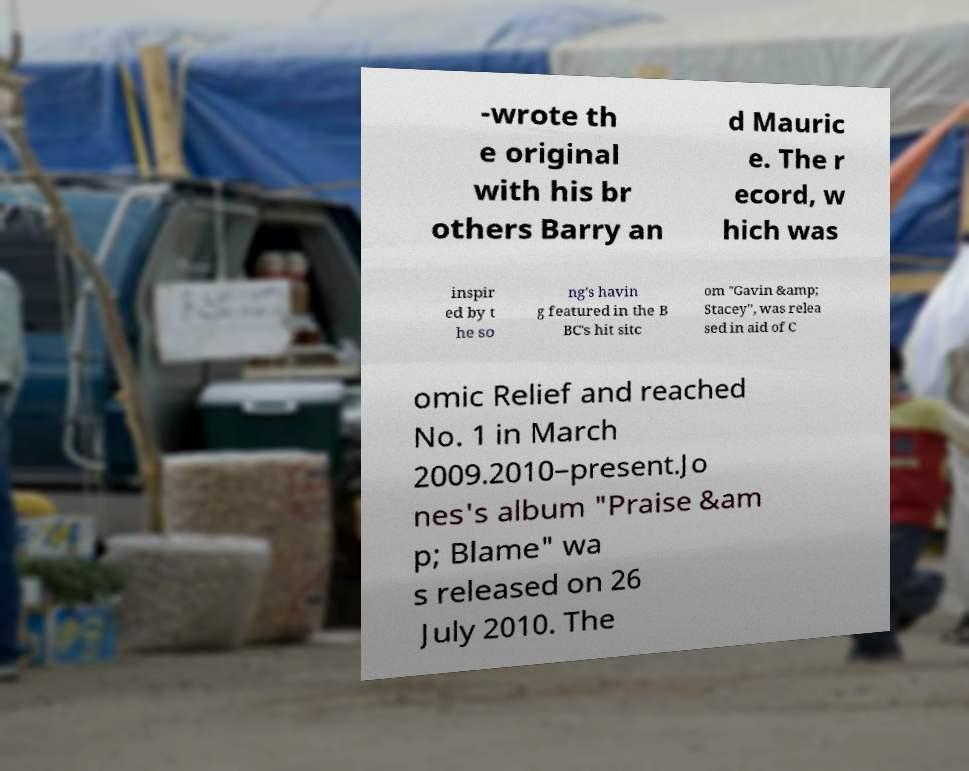I need the written content from this picture converted into text. Can you do that? -wrote th e original with his br others Barry an d Mauric e. The r ecord, w hich was inspir ed by t he so ng's havin g featured in the B BC's hit sitc om "Gavin &amp; Stacey", was relea sed in aid of C omic Relief and reached No. 1 in March 2009.2010–present.Jo nes's album "Praise &am p; Blame" wa s released on 26 July 2010. The 